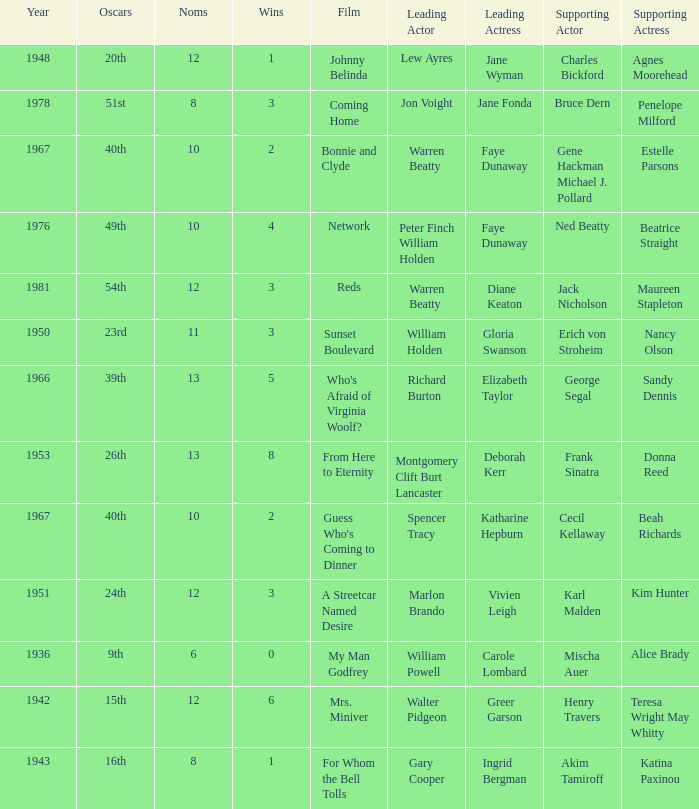Who was the leading actor in the film with a supporting actor named Cecil Kellaway? Spencer Tracy. 